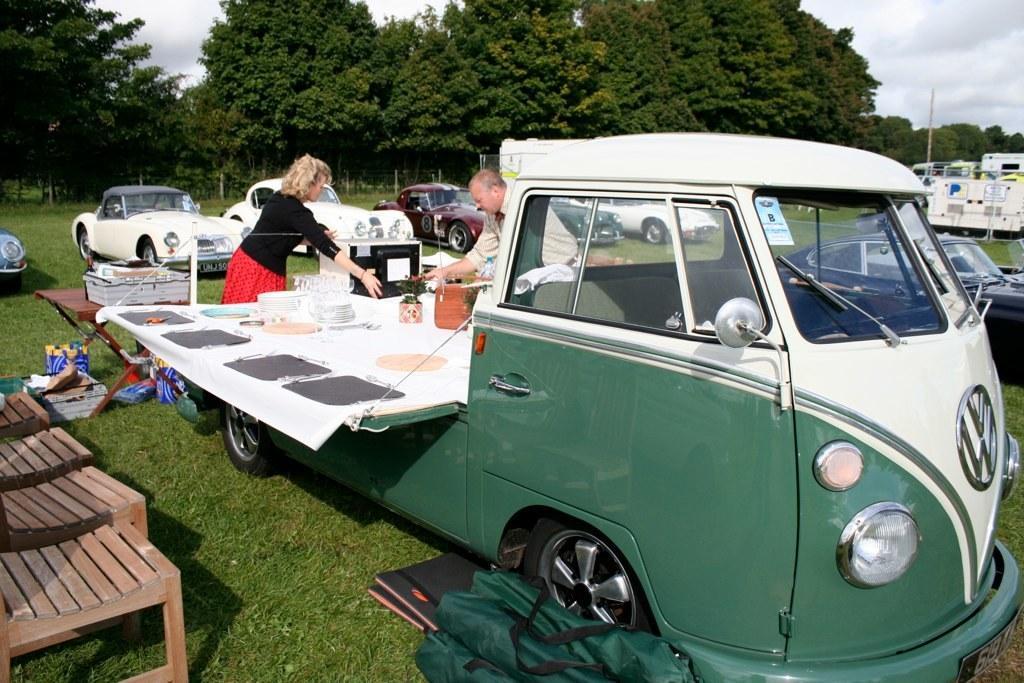Can you describe this image briefly? There is vehicle in this picture. Two members were standing in front of a vehicle. In the background there are some cars parked on the grass here. There are some trees in the background and a sky with some clouds. 